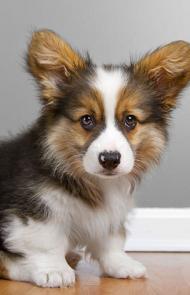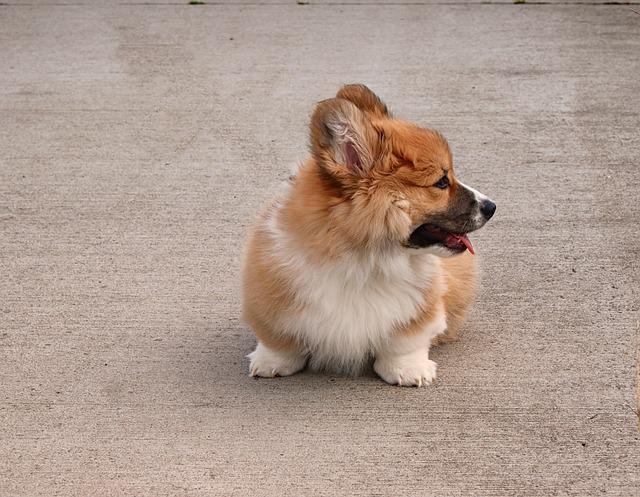The first image is the image on the left, the second image is the image on the right. Evaluate the accuracy of this statement regarding the images: "One image contains a tri-color dog that is not reclining and has its body angled to the right.". Is it true? Answer yes or no. Yes. The first image is the image on the left, the second image is the image on the right. For the images displayed, is the sentence "One dog has its tongue out." factually correct? Answer yes or no. Yes. 